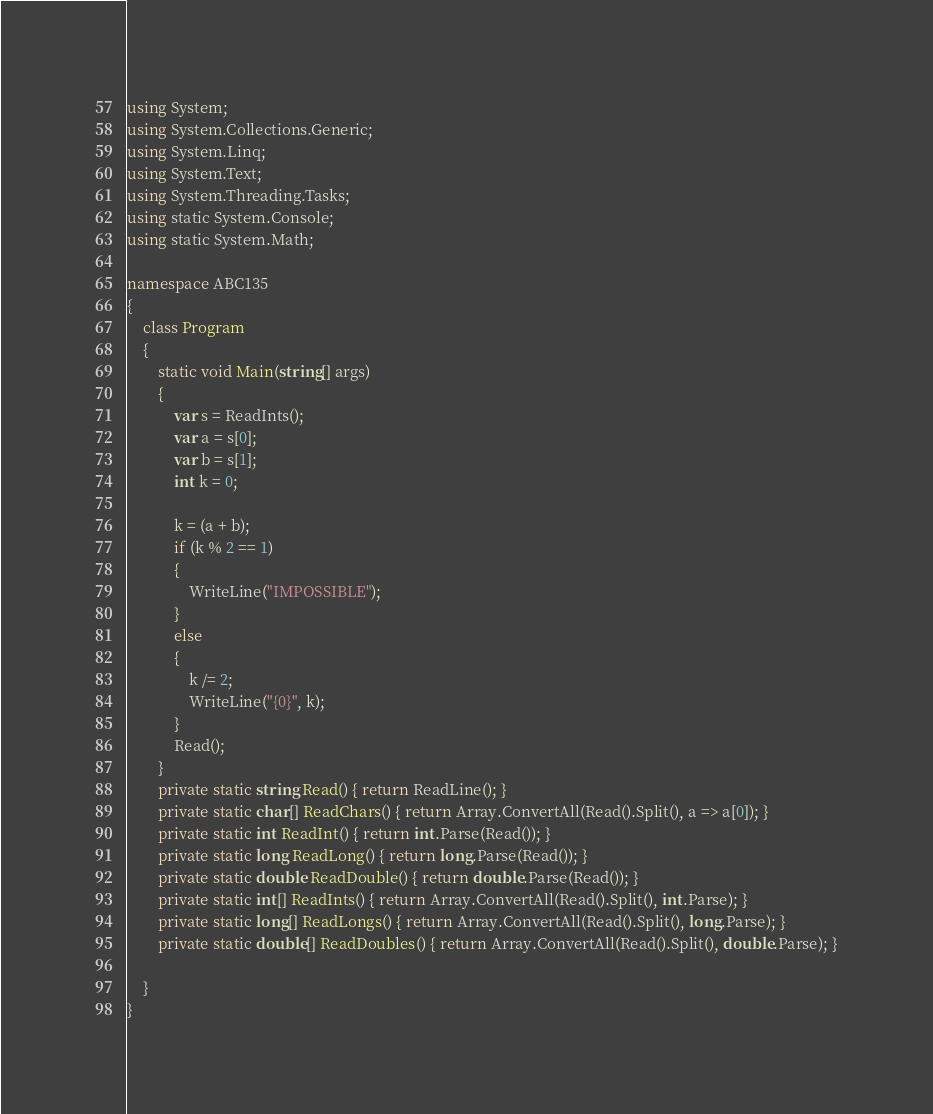<code> <loc_0><loc_0><loc_500><loc_500><_C#_>using System;
using System.Collections.Generic;
using System.Linq;
using System.Text;
using System.Threading.Tasks;
using static System.Console;
using static System.Math;

namespace ABC135
{
    class Program
    {
        static void Main(string[] args)
        {
            var s = ReadInts();
            var a = s[0];
            var b = s[1];
            int k = 0;

            k = (a + b);
            if (k % 2 == 1)
            {
                WriteLine("IMPOSSIBLE");
            }
            else
            {
                k /= 2;
                WriteLine("{0}", k);
            }
            Read();
        }
        private static string Read() { return ReadLine(); }
        private static char[] ReadChars() { return Array.ConvertAll(Read().Split(), a => a[0]); }
        private static int ReadInt() { return int.Parse(Read()); }
        private static long ReadLong() { return long.Parse(Read()); }
        private static double ReadDouble() { return double.Parse(Read()); }
        private static int[] ReadInts() { return Array.ConvertAll(Read().Split(), int.Parse); }
        private static long[] ReadLongs() { return Array.ConvertAll(Read().Split(), long.Parse); }
        private static double[] ReadDoubles() { return Array.ConvertAll(Read().Split(), double.Parse); }

    }
}
</code> 